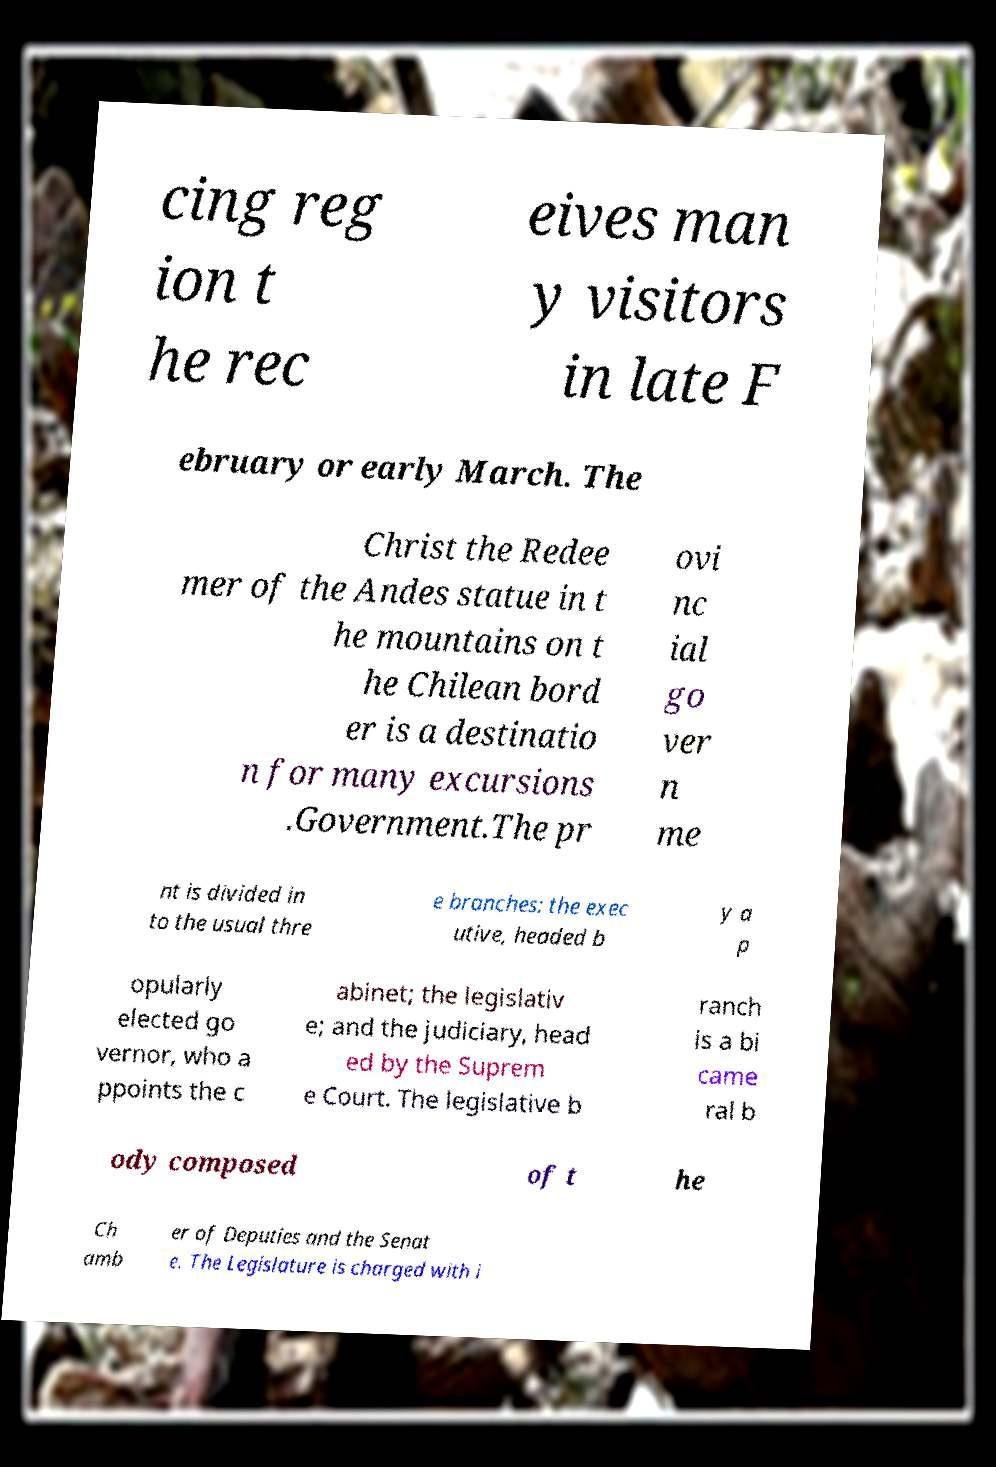What messages or text are displayed in this image? I need them in a readable, typed format. cing reg ion t he rec eives man y visitors in late F ebruary or early March. The Christ the Redee mer of the Andes statue in t he mountains on t he Chilean bord er is a destinatio n for many excursions .Government.The pr ovi nc ial go ver n me nt is divided in to the usual thre e branches: the exec utive, headed b y a p opularly elected go vernor, who a ppoints the c abinet; the legislativ e; and the judiciary, head ed by the Suprem e Court. The legislative b ranch is a bi came ral b ody composed of t he Ch amb er of Deputies and the Senat e. The Legislature is charged with i 